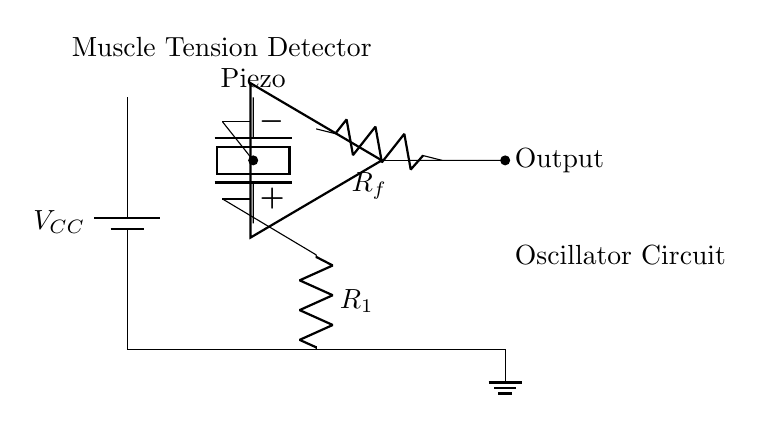What is the type of sensor used in this circuit? The circuit uses a piezoelectric sensor, which is indicated by the label "Piezo" in the diagram.
Answer: Piezoelectric What is the role of the op-amp in this circuit? The operational amplifier in the circuit amplifies the signal generated by the piezoelectric sensor to detect muscle tension and fatigue more effectively.
Answer: Amplifier What does R1 represent in this circuit? R1 in the circuit represents a resistor that is part of the op-amp configuration, which influences the gain of the amplifier.
Answer: Resistor How many resistors are in this circuit? There are two resistors shown in the circuit, labeled as R1 and Rf, which denote different parts of the amplifier feedback and input.
Answer: Two What is the purpose of the feedback resistor Rf? The feedback resistor Rf helps control the gain of the op-amp, thereby affecting the sensitivity and output response of the muscle tension detection circuit.
Answer: Gain control What is the output of this circuit referred to as? The output is simply labeled "Output" in the circuit diagram, representing the processed signal indicating muscle tension and fatigue levels.
Answer: Output What is the power supply voltage labeled as? The power supply voltage is labeled as VCC, indicating the voltage that powers the entire circuit.
Answer: VCC 